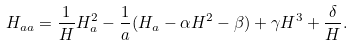<formula> <loc_0><loc_0><loc_500><loc_500>H _ { a a } = \frac { 1 } { H } H _ { a } ^ { 2 } - \frac { 1 } { a } ( H _ { a } - \alpha H ^ { 2 } - \beta ) + \gamma H ^ { 3 } + \frac { \delta } { H } .</formula> 